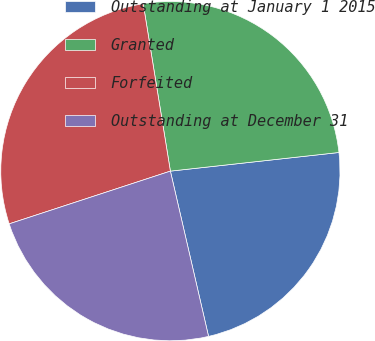Convert chart. <chart><loc_0><loc_0><loc_500><loc_500><pie_chart><fcel>Outstanding at January 1 2015<fcel>Granted<fcel>Forfeited<fcel>Outstanding at December 31<nl><fcel>23.14%<fcel>25.81%<fcel>27.47%<fcel>23.58%<nl></chart> 